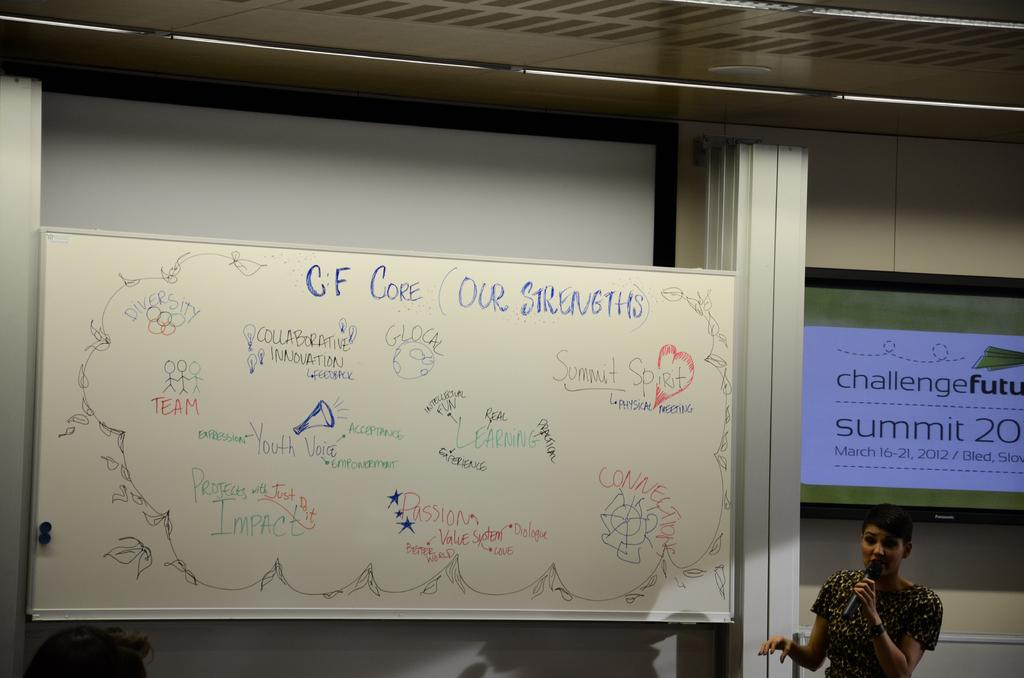What is the person in the image doing? The person is speaking in the image. What can be seen near the person? The person is in front of a microphone. What is located behind the person? There is a whiteboard behind the person. What is written on the whiteboard? There is writing on the whiteboard. What language is the person speaking in the image? The provided facts do not mention the language being spoken, so it cannot be determined from the image. What type of school is depicted in the image? There is no school present in the image; it features a person speaking in front of a microphone and a whiteboard. 